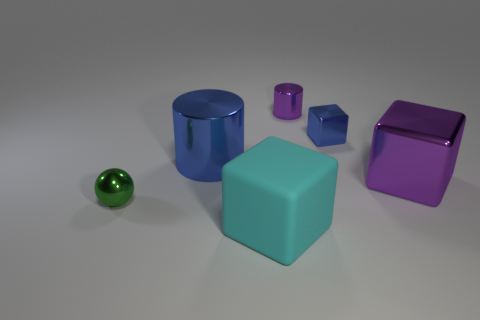How big is the block in front of the tiny metal thing to the left of the cylinder right of the cyan rubber cube?
Make the answer very short. Large. Is the material of the small object that is to the right of the small purple cylinder the same as the big block behind the sphere?
Your answer should be compact. Yes. How many other things are there of the same color as the matte cube?
Offer a terse response. 0. How many objects are either purple metal objects behind the large purple thing or metal objects to the right of the matte block?
Offer a very short reply. 3. What size is the purple metal object right of the metal object that is behind the small block?
Keep it short and to the point. Large. How big is the cyan block?
Make the answer very short. Large. There is a large metal object right of the cyan rubber thing; is it the same color as the cylinder on the right side of the big rubber block?
Provide a succinct answer. Yes. What number of other things are there of the same material as the large cyan object
Offer a very short reply. 0. Are there any big yellow shiny spheres?
Ensure brevity in your answer.  No. Does the blue thing right of the cyan cube have the same material as the big purple cube?
Make the answer very short. Yes. 